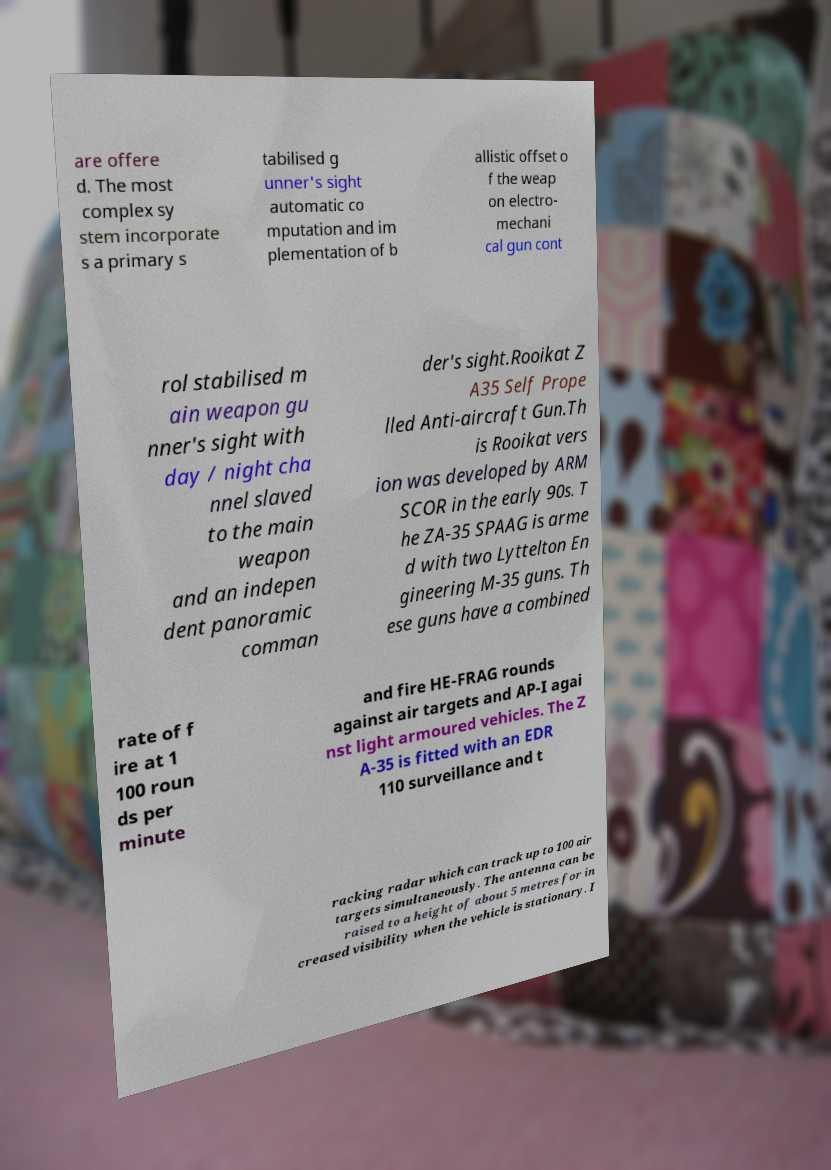Can you accurately transcribe the text from the provided image for me? are offere d. The most complex sy stem incorporate s a primary s tabilised g unner's sight automatic co mputation and im plementation of b allistic offset o f the weap on electro- mechani cal gun cont rol stabilised m ain weapon gu nner's sight with day / night cha nnel slaved to the main weapon and an indepen dent panoramic comman der's sight.Rooikat Z A35 Self Prope lled Anti-aircraft Gun.Th is Rooikat vers ion was developed by ARM SCOR in the early 90s. T he ZA-35 SPAAG is arme d with two Lyttelton En gineering M-35 guns. Th ese guns have a combined rate of f ire at 1 100 roun ds per minute and fire HE-FRAG rounds against air targets and AP-I agai nst light armoured vehicles. The Z A-35 is fitted with an EDR 110 surveillance and t racking radar which can track up to 100 air targets simultaneously. The antenna can be raised to a height of about 5 metres for in creased visibility when the vehicle is stationary. I 